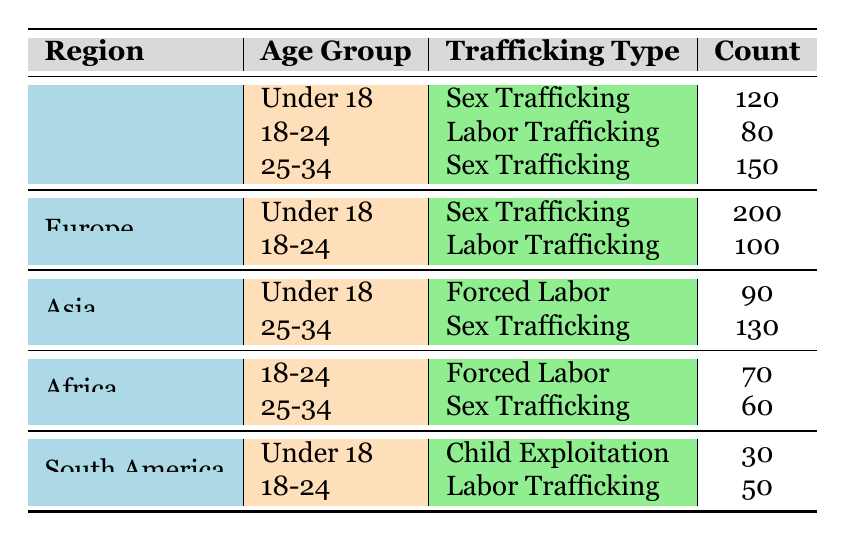What is the total number of reported cases of sex trafficking in North America? In North America, sex trafficking is reported for two age groups: Under 18 (120 cases) and 25-34 (150 cases). Adding these together gives 120 + 150 = 270.
Answer: 270 Which region has the highest number of cases of labor trafficking reported among the 18-24 age group? In the age group 18-24 for labor trafficking, North America reports 80 cases, Europe reports 100 cases, Africa reports 70 cases, and South America reports 50 cases. The highest is 100 cases in Europe.
Answer: Europe Is there any case of child exploitation reported in Africa? In Africa, the types of trafficking reported are forced labor for the 18-24 age group (70 cases) and sex trafficking for the 25-34 age group (60 cases). There are no reported cases of child exploitation in Africa.
Answer: No What is the average number of cases reported for sex trafficking across all regions and age groups? The total cases of sex trafficking are: North America (120 + 150 = 270), Europe (200), Asia (130), Africa (60). Calculating the average: (270 + 200 + 130 + 60) / 4 = 165.
Answer: 165 In which age group does South America report the least number of trafficking cases? South America has reported for two age groups: Under 18 (30 cases of child exploitation) and 18-24 (50 cases of labor trafficking). The least is 30 cases in Under 18.
Answer: Under 18 What percentage of reported cases of trafficking in Asia are due to forced labor for the Under 18 age group? In Asia, there are 90 cases of forced labor for Under 18 and 130 cases of sex trafficking for 25-34. The total for Asia is 90 + 130 = 220. The percentage of forced labor is (90 / 220) * 100 = 40.91%.
Answer: 40.91% Do more cases of trafficking occur in Europe than in South America? In Europe, the total cases are 200 (Under 18) + 100 (18-24) = 300, while in South America, there are 30 (Under 18) + 50 (18-24) = 80. Since 300 > 80, Europe has more cases.
Answer: Yes What is the difference in the number of reported sex trafficking cases between North America and Asia? In North America, sex trafficking cases are 270 (120 + 150). In Asia, the only reported sex trafficking is 130 cases. The difference is 270 - 130 = 140.
Answer: 140 